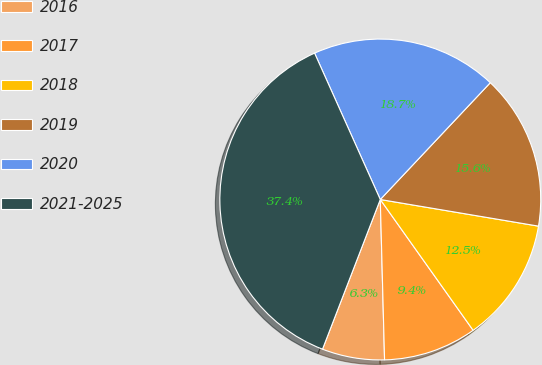Convert chart to OTSL. <chart><loc_0><loc_0><loc_500><loc_500><pie_chart><fcel>2016<fcel>2017<fcel>2018<fcel>2019<fcel>2020<fcel>2021-2025<nl><fcel>6.29%<fcel>9.4%<fcel>12.52%<fcel>15.63%<fcel>18.74%<fcel>37.42%<nl></chart> 